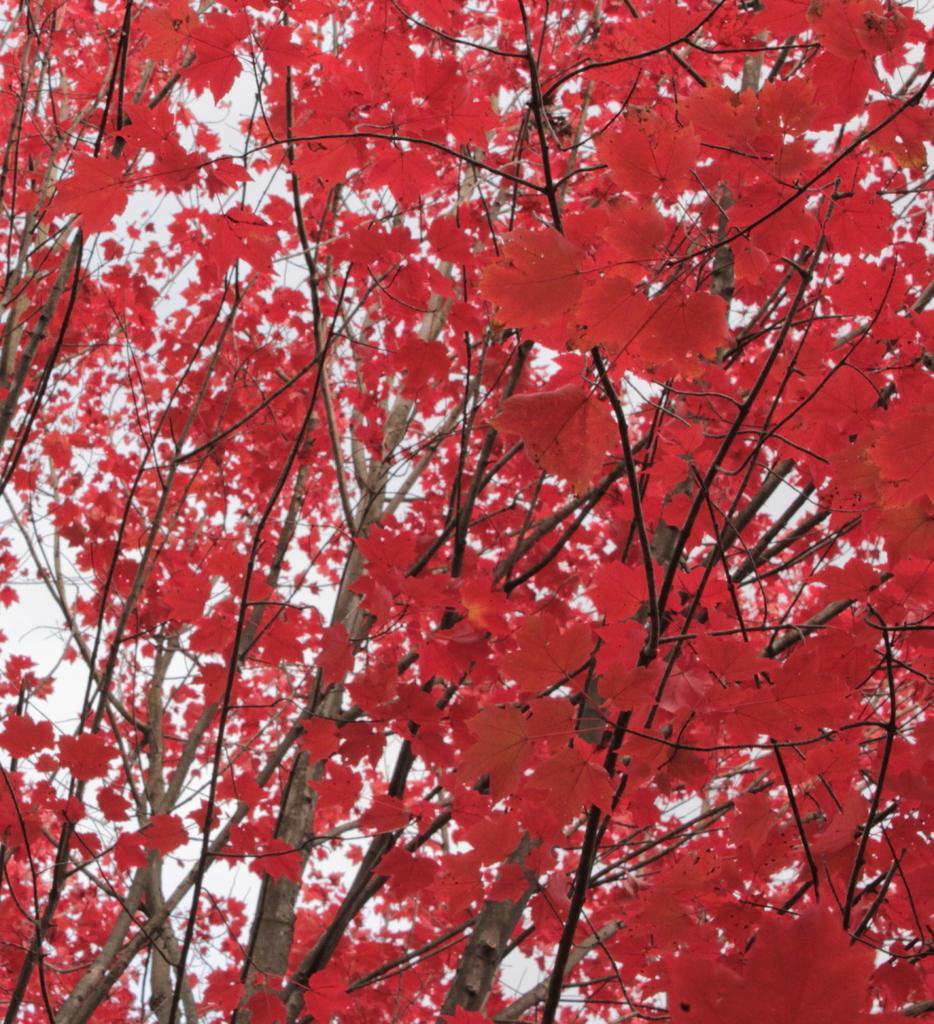How would you summarize this image in a sentence or two? In this image we can see trees and sky. 